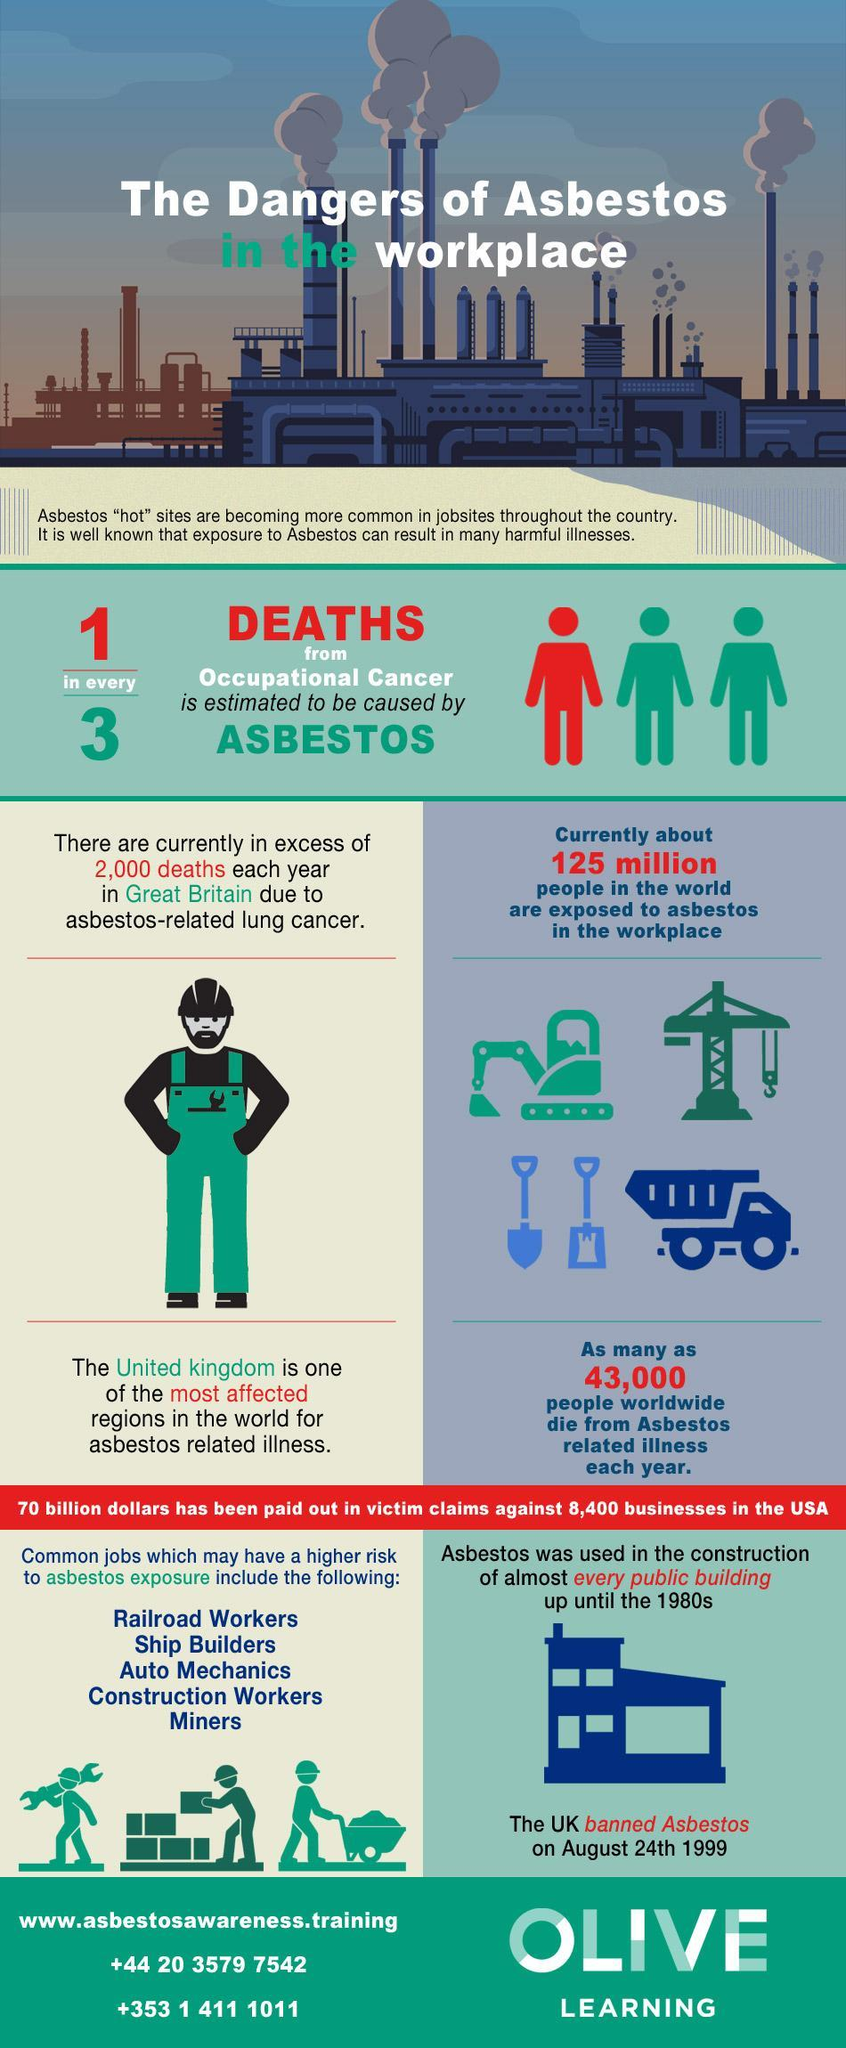In the first graphics after the heading, what is written inside quotation mark?
Answer the question with a short phrase. hot Which cancer is caused by asbestos? lung cancer What percentage of death from occupational cancer are caused by asbestos? 33.3 Which jobs have higher risk of asbestos exposure apart from minors and construction workers? railroad workers, ship builders, auto mechanics in which color the number "43000" is written - red or black? red 